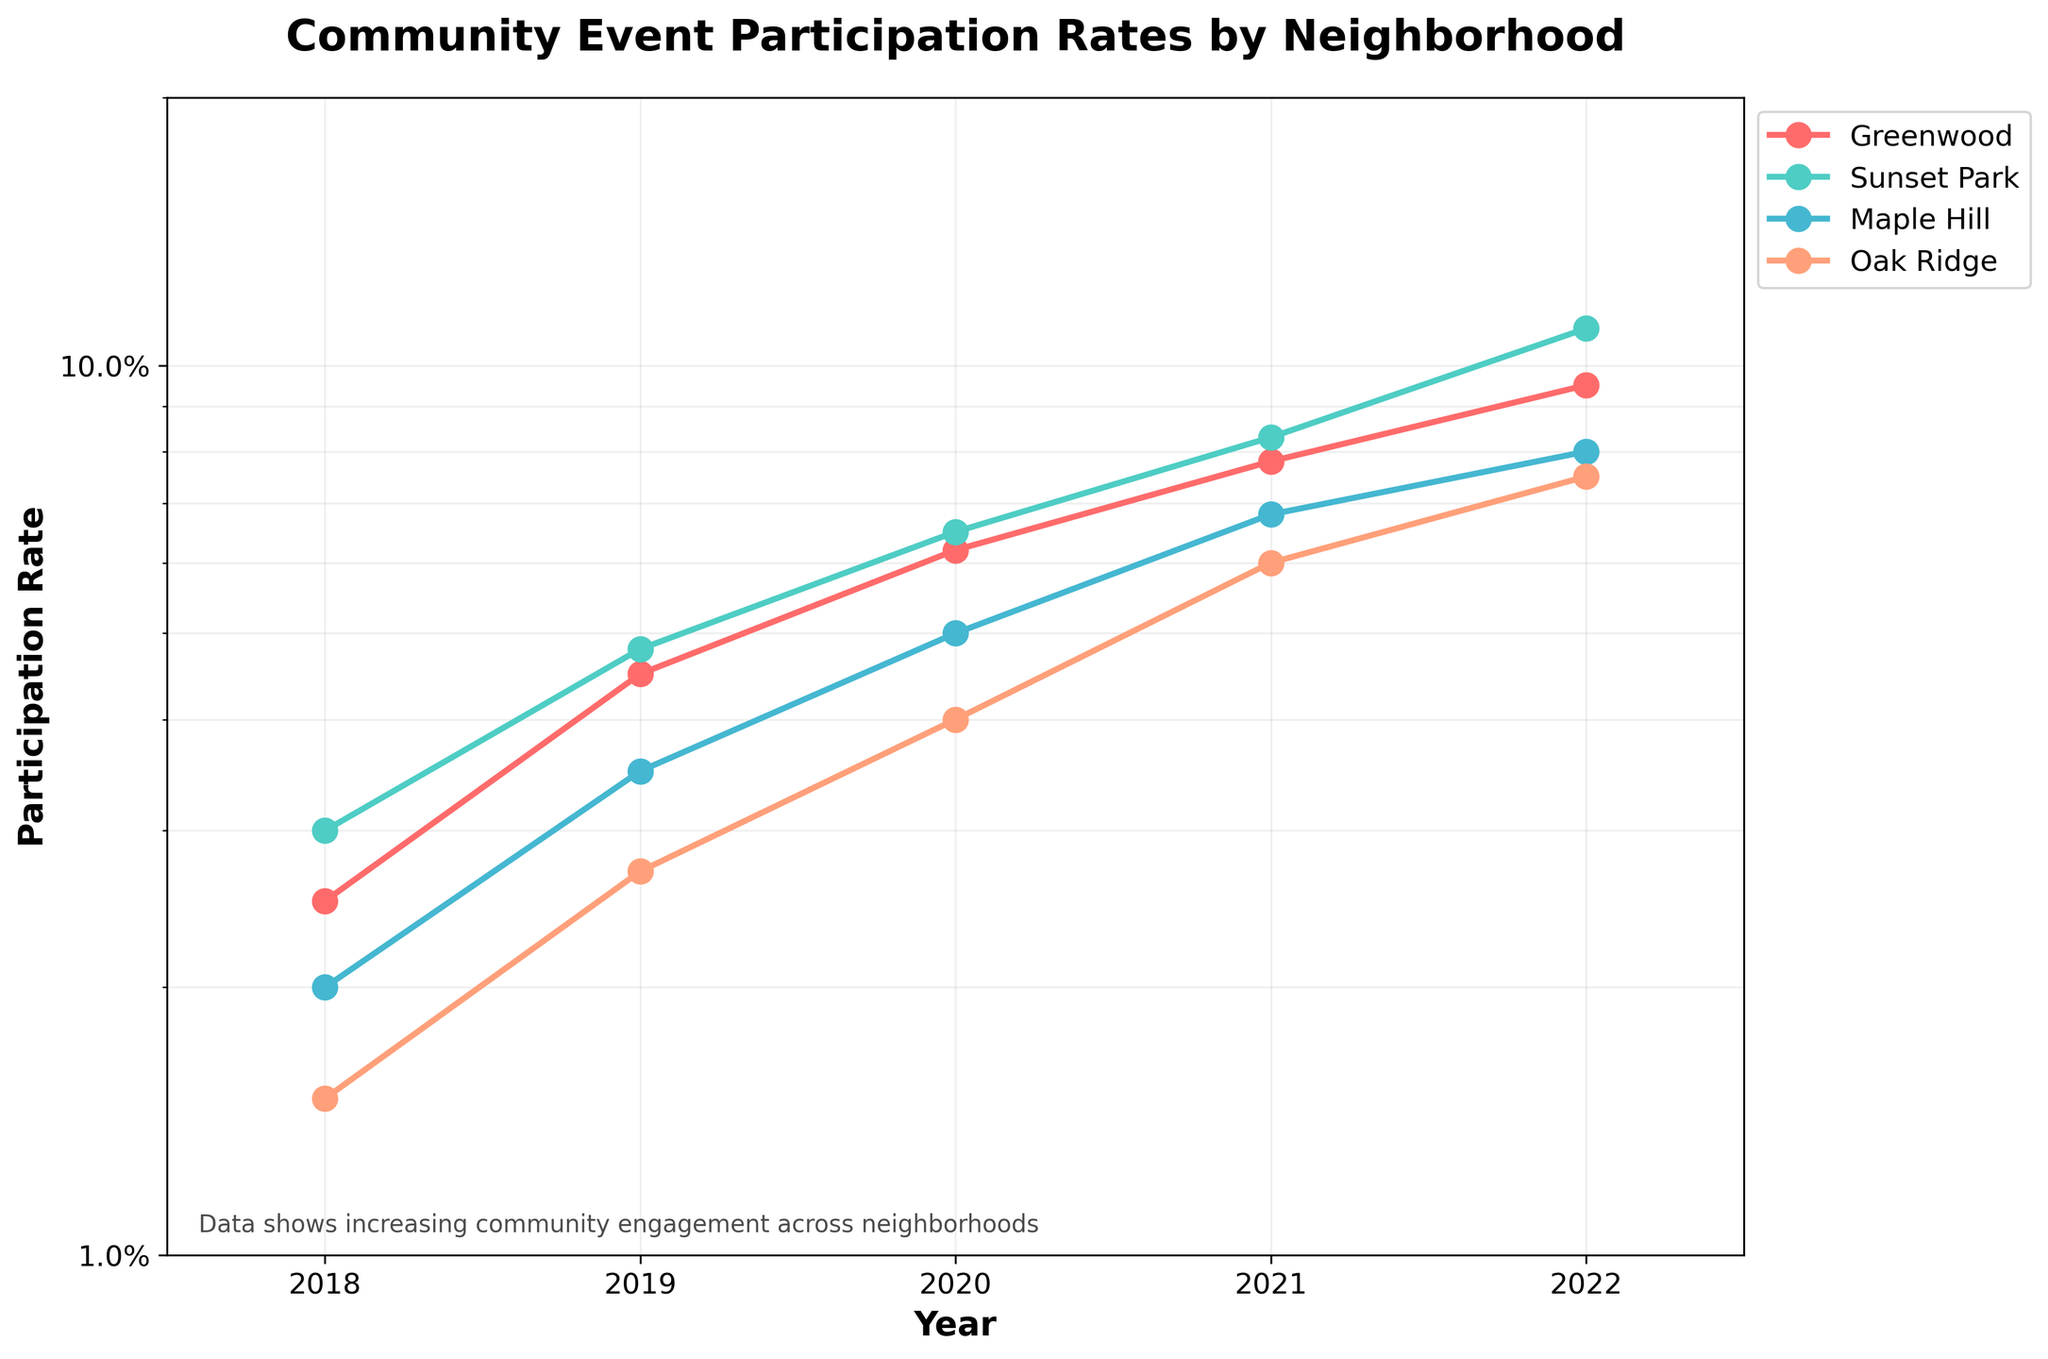How many neighborhoods are included in the figure? There are four distinct lines, each representing a different neighborhood. These are Greenwood, Sunset Park, Maple Hill, and Oak Ridge.
Answer: 4 Which neighborhood had the highest participation rate in 2022? The marker for each neighborhood in 2022 shows Sunset Park reaching the highest participation rate. This can be visually identified as the line for Sunset Park extends the highest on the vertical axis at the 2022 mark.
Answer: Sunset Park How does Greenwood's participation rate trend over the years? Greenwood's participation rate increases every year from 2018 to 2022. This is indicated by a consistently upward-sloping line.
Answer: Increases Which neighborhood shows the greatest increase in participation rate from 2018 to 2022? Calculate the difference in participation rates from 2018 to 2022 for each neighborhood. Sunset Park increases from 0.030 to 0.110, which is the highest absolute increase among all neighborhoods.
Answer: Sunset Park In which year did Maple Hill surpass Oak Ridge in participation rates for the first time? Track the intersect point between the lines for Maple Hill and Oak Ridge. The first crossing point appears between the years 2019 and 2020, with Maple Hill surpassing Oak Ridge in the 2020 data point.
Answer: 2020 What is the overall trend shown in the plot for the participation rates? The plot shows an overall increasing trend for community event participation rates across all neighborhoods from 2018 to 2022. This is evident from the upward slopes of all the lines.
Answer: Increasing Compare the participation rate of Sunset Park and Greenwood in 2021. Which one was higher? In 2021, by examining the vertical positions of the markers along the y-axis, Sunset Park's participation rate is higher than Greenwood's since the marker for Sunset Park is positioned above that for Greenwood.
Answer: Sunset Park What might the text annotation "Data shows increasing community engagement across neighborhoods" suggest about the plot's content? The annotation suggests an overall positive trend in community engagement, which is visually corroborated by the rising trends of participation rates in all neighborhoods over the years.
Answer: Increasing trend What is the range of the participation rate values presented on the y-axis? The y-axis is based on a log scale ranging from 0.01 to 0.2, as indicated by the set limits in the plot's configuration.
Answer: 0.01 to 0.2 Which neighborhood had the lowest participation rate in 2019, and what was it? By referencing the vertical positions of the 2019 markers, Oak Ridge had the lowest participation rate, which lies slightly above the 0.02 mark.
Answer: Oak Ridge, around 0.027 